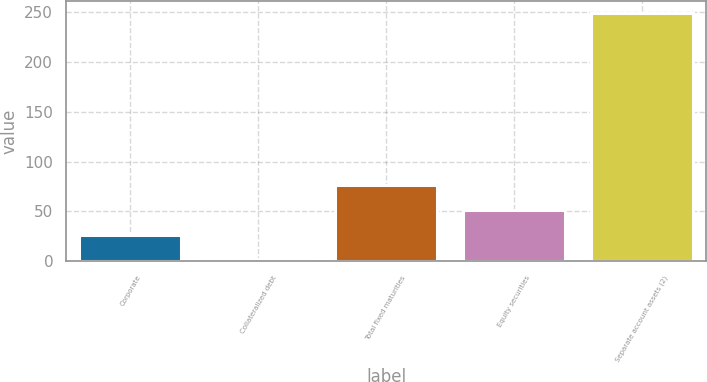<chart> <loc_0><loc_0><loc_500><loc_500><bar_chart><fcel>Corporate<fcel>Collateralized debt<fcel>Total fixed maturities<fcel>Equity securities<fcel>Separate account assets (2)<nl><fcel>26.61<fcel>1.9<fcel>76.03<fcel>51.32<fcel>249<nl></chart> 